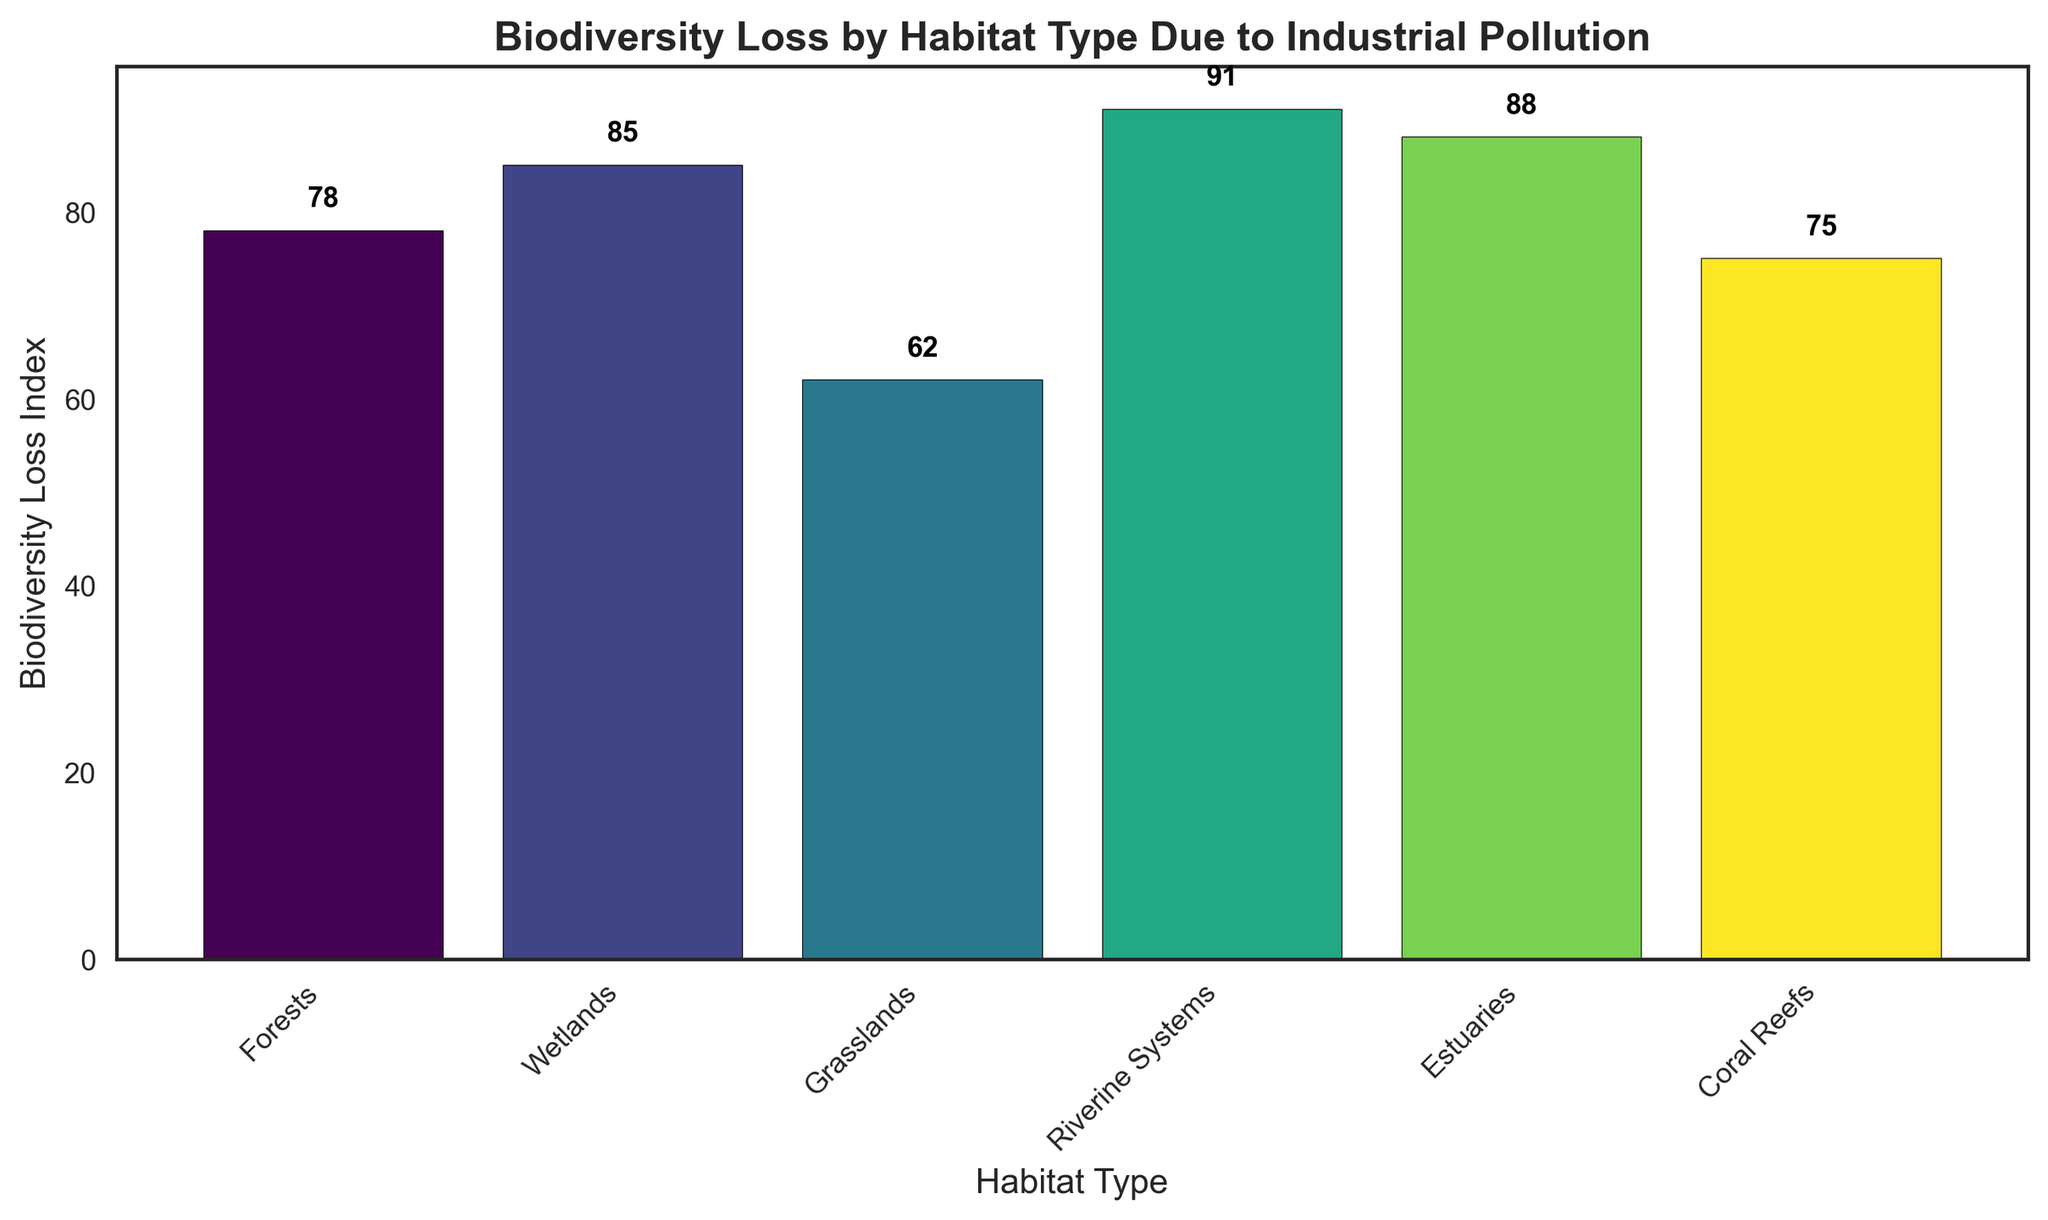Which habitat type has the highest biodiversity loss index? By looking at the height of the bars in the chart, the "Riverine Systems" bar is the tallest, indicating the highest biodiversity loss index. It has a value of 91.
Answer: Riverine Systems What is the difference in biodiversity loss index between Coral Reefs and Grasslands? The biodiversity loss index for Coral Reefs is 75 and for Grasslands is 62. The difference is calculated as 75 - 62 = 13.
Answer: 13 Which habitat type has the lowest biodiversity loss index? By comparing the heights of the bars, the "Grasslands" bar is the shortest, indicating the lowest biodiversity loss index. It has a value of 62.
Answer: Grasslands How much greater is the biodiversity loss in Estuaries compared to Forests? The value for Estuaries is 88 and for Forests is 78. The difference is calculated as 88 - 78 = 10.
Answer: 10 Which two habitat types have the closest biodiversity loss indexes? By comparing the bar heights visually, "Forests" with a value of 78 and "Coral Reefs" with a value of 75 have the closest values. The difference between them is just 3.
Answer: Forests and Coral Reefs What is the average biodiversity loss index across all habitat types? The biodiversity loss indexes are 78, 85, 62, 91, 88, and 75. To find the average, sum these values and divide by the number of entries. (78 + 85 + 62 + 91 + 88 + 75) / 6 = 79.83.
Answer: 79.83 Are there more habitats with a biodiversity loss index greater than or equal to 85 or less than 85? The habitats with an index >= 85 are Wetlands (85), Riverine Systems (91), and Estuaries (88), making 3. Those with an index < 85 are Forests (78), Grasslands (62), and Coral Reefs (75), also making 3. So they are equal.
Answer: Equal Which bar is the third largest? By ranking the bars by height: Riverine Systems (91), Estuaries (88), and then Wetlands (85) as third.
Answer: Wetlands By how much does the biodiversity loss index in Riverine Systems exceed the combined total of Grasslands and Coral Reefs? The Riverine Systems index is 91. The combined total of Grasslands (62) and Coral Reefs (75) is 62 + 75 = 137. The index for Riverine Systems is less than this total.
Answer: N/A What is the combined biodiversity loss index for habitats with an index above the overall average? The overall average is 79.83. Habitats above this average are Wetlands (85), Riverine Systems (91), and Estuaries (88). Combined, this is 85 + 91 + 88 = 264.
Answer: 264 